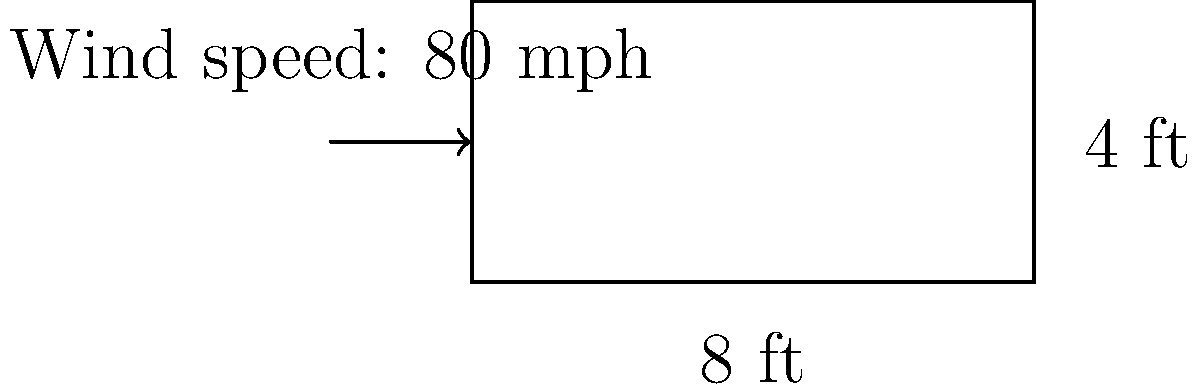As you're planning to upgrade the scoreboard at your local baseball field, you need to determine the wind load on the new scoreboard. The proposed scoreboard is 8 feet wide and 4 feet tall. If the maximum wind speed in your area is 80 mph, what is the total wind load on the scoreboard in pounds? (Use the simplified formula: Wind Load = 0.00256 * v^2 * A, where v is wind speed in mph and A is area in square feet) To calculate the wind load on the scoreboard, we'll follow these steps:

1. Calculate the area of the scoreboard:
   $A = \text{width} \times \text{height} = 8 \text{ ft} \times 4 \text{ ft} = 32 \text{ sq ft}$

2. Use the given wind speed:
   $v = 80 \text{ mph}$

3. Apply the simplified wind load formula:
   $\text{Wind Load} = 0.00256 \times v^2 \times A$
   
   $\text{Wind Load} = 0.00256 \times (80 \text{ mph})^2 \times 32 \text{ sq ft}$

4. Calculate:
   $\text{Wind Load} = 0.00256 \times 6400 \times 32$
   $\text{Wind Load} = 524.288 \text{ lbs}$

5. Round to the nearest whole number:
   $\text{Wind Load} \approx 524 \text{ lbs}$

This wind load represents the total force exerted on the scoreboard by the wind at its maximum speed.
Answer: 524 lbs 